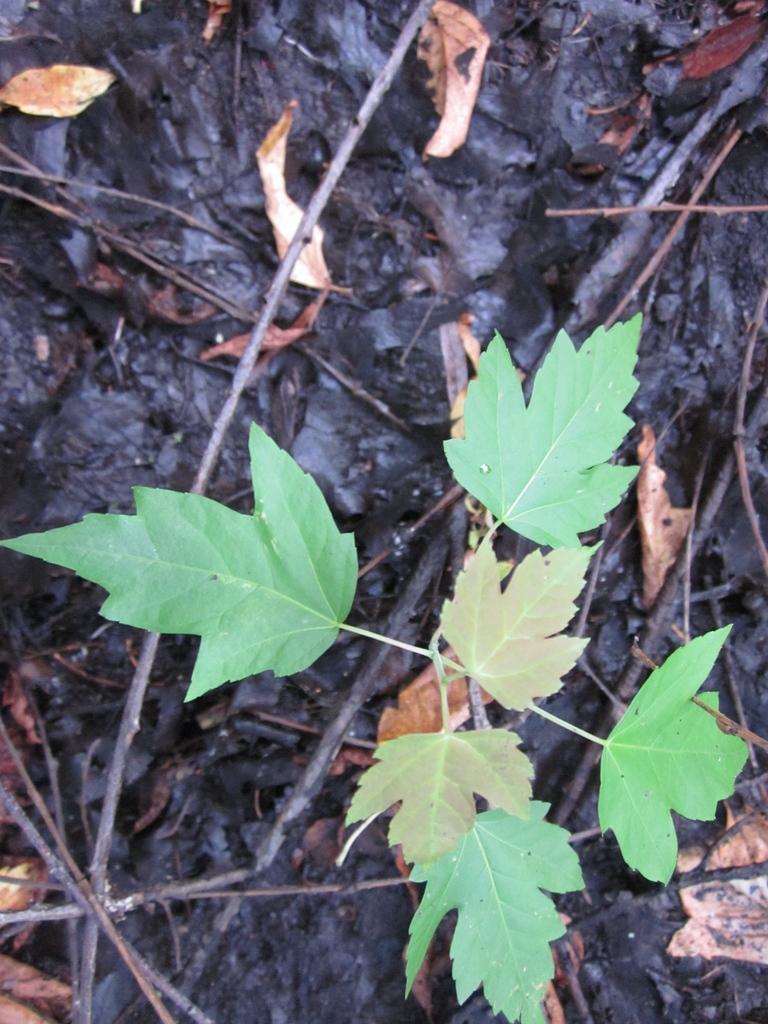Can you describe this image briefly? In the image we can see some leaves and stems. 